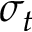<formula> <loc_0><loc_0><loc_500><loc_500>\sigma _ { t }</formula> 